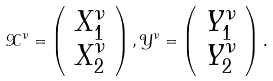<formula> <loc_0><loc_0><loc_500><loc_500>\mathcal { X } ^ { \nu } = \left ( \begin{array} { c c } X _ { 1 } ^ { \nu } \\ X _ { 2 } ^ { \nu } \\ \end{array} \right ) , \mathcal { Y } ^ { \nu } = \left ( \begin{array} { c c } Y _ { 1 } ^ { \nu } \\ Y _ { 2 } ^ { \nu } \\ \end{array} \right ) .</formula> 